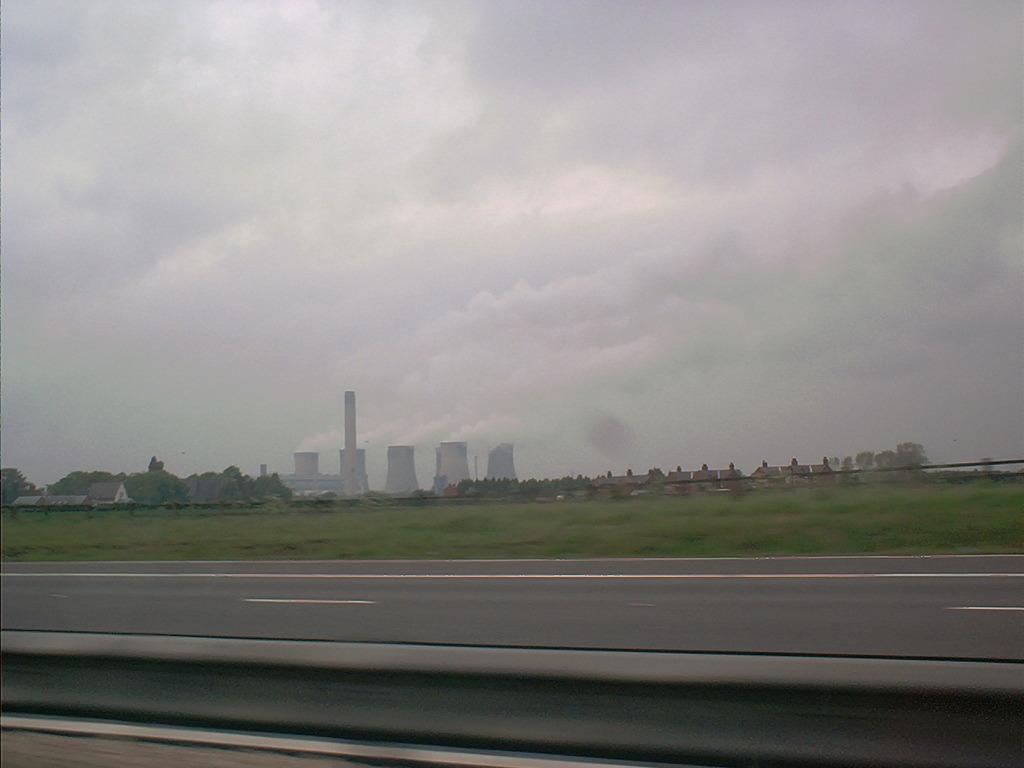Could you give a brief overview of what you see in this image? This image is clicked from a vehicle. At the bottom, there is a road. In the background, there are buildings along with green grass. To the top, there are clouds in the sky. 